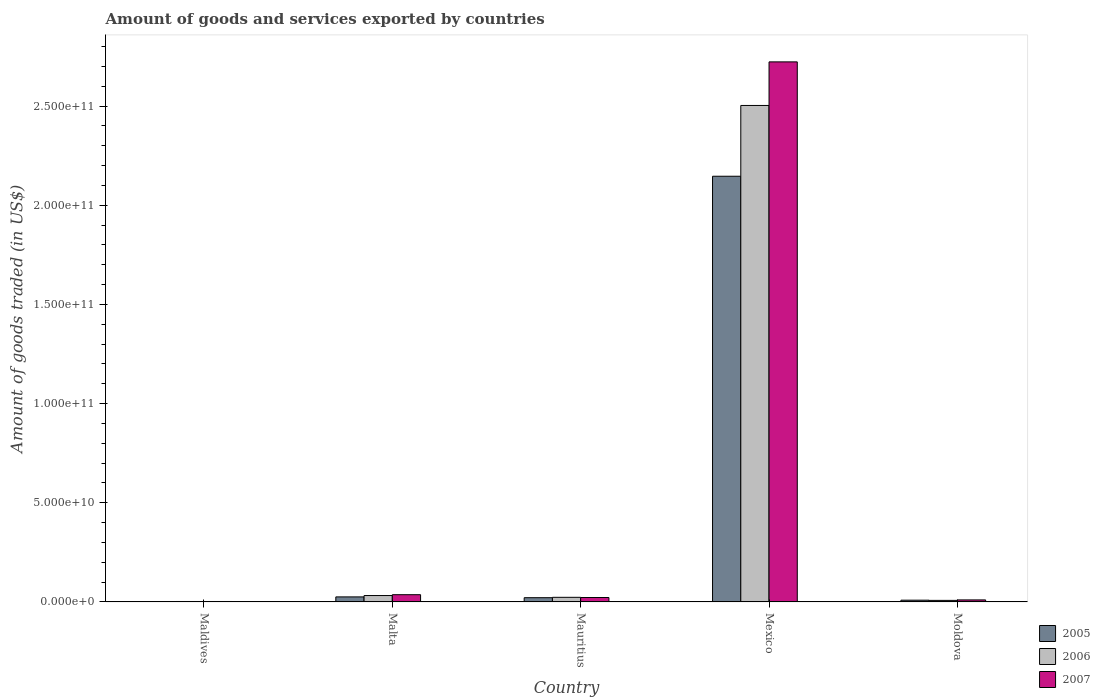How many different coloured bars are there?
Make the answer very short. 3. Are the number of bars on each tick of the X-axis equal?
Make the answer very short. Yes. What is the label of the 4th group of bars from the left?
Give a very brief answer. Mexico. In how many cases, is the number of bars for a given country not equal to the number of legend labels?
Your answer should be compact. 0. What is the total amount of goods and services exported in 2005 in Maldives?
Provide a succinct answer. 1.62e+08. Across all countries, what is the maximum total amount of goods and services exported in 2007?
Provide a short and direct response. 2.72e+11. Across all countries, what is the minimum total amount of goods and services exported in 2006?
Provide a succinct answer. 2.25e+08. In which country was the total amount of goods and services exported in 2007 maximum?
Your response must be concise. Mexico. In which country was the total amount of goods and services exported in 2005 minimum?
Your answer should be very brief. Maldives. What is the total total amount of goods and services exported in 2005 in the graph?
Make the answer very short. 2.20e+11. What is the difference between the total amount of goods and services exported in 2007 in Maldives and that in Moldova?
Your answer should be compact. -7.99e+08. What is the difference between the total amount of goods and services exported in 2007 in Malta and the total amount of goods and services exported in 2005 in Mexico?
Make the answer very short. -2.11e+11. What is the average total amount of goods and services exported in 2007 per country?
Give a very brief answer. 5.59e+1. What is the difference between the total amount of goods and services exported of/in 2005 and total amount of goods and services exported of/in 2006 in Mauritius?
Provide a short and direct response. -1.90e+08. What is the ratio of the total amount of goods and services exported in 2006 in Mauritius to that in Moldova?
Ensure brevity in your answer.  2.96. Is the difference between the total amount of goods and services exported in 2005 in Mauritius and Mexico greater than the difference between the total amount of goods and services exported in 2006 in Mauritius and Mexico?
Your response must be concise. Yes. What is the difference between the highest and the second highest total amount of goods and services exported in 2007?
Your response must be concise. 2.69e+11. What is the difference between the highest and the lowest total amount of goods and services exported in 2005?
Keep it short and to the point. 2.14e+11. Is it the case that in every country, the sum of the total amount of goods and services exported in 2007 and total amount of goods and services exported in 2005 is greater than the total amount of goods and services exported in 2006?
Keep it short and to the point. Yes. How many countries are there in the graph?
Ensure brevity in your answer.  5. What is the difference between two consecutive major ticks on the Y-axis?
Provide a short and direct response. 5.00e+1. Does the graph contain any zero values?
Give a very brief answer. No. Where does the legend appear in the graph?
Offer a terse response. Bottom right. What is the title of the graph?
Provide a short and direct response. Amount of goods and services exported by countries. What is the label or title of the X-axis?
Make the answer very short. Country. What is the label or title of the Y-axis?
Keep it short and to the point. Amount of goods traded (in US$). What is the Amount of goods traded (in US$) in 2005 in Maldives?
Ensure brevity in your answer.  1.62e+08. What is the Amount of goods traded (in US$) of 2006 in Maldives?
Your answer should be very brief. 2.25e+08. What is the Amount of goods traded (in US$) of 2007 in Maldives?
Your answer should be very brief. 2.27e+08. What is the Amount of goods traded (in US$) in 2005 in Malta?
Provide a short and direct response. 2.54e+09. What is the Amount of goods traded (in US$) of 2006 in Malta?
Provide a succinct answer. 3.23e+09. What is the Amount of goods traded (in US$) of 2007 in Malta?
Offer a terse response. 3.66e+09. What is the Amount of goods traded (in US$) in 2005 in Mauritius?
Keep it short and to the point. 2.14e+09. What is the Amount of goods traded (in US$) in 2006 in Mauritius?
Give a very brief answer. 2.33e+09. What is the Amount of goods traded (in US$) in 2007 in Mauritius?
Ensure brevity in your answer.  2.24e+09. What is the Amount of goods traded (in US$) in 2005 in Mexico?
Make the answer very short. 2.15e+11. What is the Amount of goods traded (in US$) of 2006 in Mexico?
Ensure brevity in your answer.  2.50e+11. What is the Amount of goods traded (in US$) in 2007 in Mexico?
Provide a short and direct response. 2.72e+11. What is the Amount of goods traded (in US$) in 2005 in Moldova?
Provide a short and direct response. 8.86e+08. What is the Amount of goods traded (in US$) of 2006 in Moldova?
Give a very brief answer. 7.87e+08. What is the Amount of goods traded (in US$) in 2007 in Moldova?
Make the answer very short. 1.03e+09. Across all countries, what is the maximum Amount of goods traded (in US$) of 2005?
Keep it short and to the point. 2.15e+11. Across all countries, what is the maximum Amount of goods traded (in US$) of 2006?
Your answer should be very brief. 2.50e+11. Across all countries, what is the maximum Amount of goods traded (in US$) in 2007?
Provide a succinct answer. 2.72e+11. Across all countries, what is the minimum Amount of goods traded (in US$) of 2005?
Offer a very short reply. 1.62e+08. Across all countries, what is the minimum Amount of goods traded (in US$) of 2006?
Ensure brevity in your answer.  2.25e+08. Across all countries, what is the minimum Amount of goods traded (in US$) in 2007?
Ensure brevity in your answer.  2.27e+08. What is the total Amount of goods traded (in US$) of 2005 in the graph?
Give a very brief answer. 2.20e+11. What is the total Amount of goods traded (in US$) in 2006 in the graph?
Your answer should be compact. 2.57e+11. What is the total Amount of goods traded (in US$) in 2007 in the graph?
Offer a very short reply. 2.79e+11. What is the difference between the Amount of goods traded (in US$) of 2005 in Maldives and that in Malta?
Your answer should be compact. -2.38e+09. What is the difference between the Amount of goods traded (in US$) in 2006 in Maldives and that in Malta?
Provide a succinct answer. -3.00e+09. What is the difference between the Amount of goods traded (in US$) of 2007 in Maldives and that in Malta?
Provide a short and direct response. -3.43e+09. What is the difference between the Amount of goods traded (in US$) of 2005 in Maldives and that in Mauritius?
Your answer should be very brief. -1.98e+09. What is the difference between the Amount of goods traded (in US$) of 2006 in Maldives and that in Mauritius?
Keep it short and to the point. -2.10e+09. What is the difference between the Amount of goods traded (in US$) of 2007 in Maldives and that in Mauritius?
Make the answer very short. -2.01e+09. What is the difference between the Amount of goods traded (in US$) in 2005 in Maldives and that in Mexico?
Make the answer very short. -2.14e+11. What is the difference between the Amount of goods traded (in US$) in 2006 in Maldives and that in Mexico?
Your response must be concise. -2.50e+11. What is the difference between the Amount of goods traded (in US$) of 2007 in Maldives and that in Mexico?
Keep it short and to the point. -2.72e+11. What is the difference between the Amount of goods traded (in US$) of 2005 in Maldives and that in Moldova?
Keep it short and to the point. -7.24e+08. What is the difference between the Amount of goods traded (in US$) of 2006 in Maldives and that in Moldova?
Provide a short and direct response. -5.62e+08. What is the difference between the Amount of goods traded (in US$) in 2007 in Maldives and that in Moldova?
Make the answer very short. -7.99e+08. What is the difference between the Amount of goods traded (in US$) in 2005 in Malta and that in Mauritius?
Ensure brevity in your answer.  4.06e+08. What is the difference between the Amount of goods traded (in US$) of 2006 in Malta and that in Mauritius?
Keep it short and to the point. 8.99e+08. What is the difference between the Amount of goods traded (in US$) in 2007 in Malta and that in Mauritius?
Provide a succinct answer. 1.42e+09. What is the difference between the Amount of goods traded (in US$) in 2005 in Malta and that in Mexico?
Ensure brevity in your answer.  -2.12e+11. What is the difference between the Amount of goods traded (in US$) of 2006 in Malta and that in Mexico?
Make the answer very short. -2.47e+11. What is the difference between the Amount of goods traded (in US$) of 2007 in Malta and that in Mexico?
Offer a very short reply. -2.69e+11. What is the difference between the Amount of goods traded (in US$) of 2005 in Malta and that in Moldova?
Your answer should be very brief. 1.66e+09. What is the difference between the Amount of goods traded (in US$) of 2006 in Malta and that in Moldova?
Give a very brief answer. 2.44e+09. What is the difference between the Amount of goods traded (in US$) of 2007 in Malta and that in Moldova?
Provide a succinct answer. 2.63e+09. What is the difference between the Amount of goods traded (in US$) in 2005 in Mauritius and that in Mexico?
Keep it short and to the point. -2.12e+11. What is the difference between the Amount of goods traded (in US$) of 2006 in Mauritius and that in Mexico?
Provide a short and direct response. -2.48e+11. What is the difference between the Amount of goods traded (in US$) of 2007 in Mauritius and that in Mexico?
Offer a terse response. -2.70e+11. What is the difference between the Amount of goods traded (in US$) of 2005 in Mauritius and that in Moldova?
Provide a short and direct response. 1.25e+09. What is the difference between the Amount of goods traded (in US$) of 2006 in Mauritius and that in Moldova?
Offer a terse response. 1.54e+09. What is the difference between the Amount of goods traded (in US$) in 2007 in Mauritius and that in Moldova?
Ensure brevity in your answer.  1.21e+09. What is the difference between the Amount of goods traded (in US$) in 2005 in Mexico and that in Moldova?
Your response must be concise. 2.14e+11. What is the difference between the Amount of goods traded (in US$) in 2006 in Mexico and that in Moldova?
Your answer should be compact. 2.50e+11. What is the difference between the Amount of goods traded (in US$) in 2007 in Mexico and that in Moldova?
Your answer should be compact. 2.71e+11. What is the difference between the Amount of goods traded (in US$) of 2005 in Maldives and the Amount of goods traded (in US$) of 2006 in Malta?
Provide a short and direct response. -3.07e+09. What is the difference between the Amount of goods traded (in US$) of 2005 in Maldives and the Amount of goods traded (in US$) of 2007 in Malta?
Make the answer very short. -3.50e+09. What is the difference between the Amount of goods traded (in US$) in 2006 in Maldives and the Amount of goods traded (in US$) in 2007 in Malta?
Keep it short and to the point. -3.43e+09. What is the difference between the Amount of goods traded (in US$) of 2005 in Maldives and the Amount of goods traded (in US$) of 2006 in Mauritius?
Give a very brief answer. -2.17e+09. What is the difference between the Amount of goods traded (in US$) of 2005 in Maldives and the Amount of goods traded (in US$) of 2007 in Mauritius?
Ensure brevity in your answer.  -2.08e+09. What is the difference between the Amount of goods traded (in US$) of 2006 in Maldives and the Amount of goods traded (in US$) of 2007 in Mauritius?
Offer a very short reply. -2.01e+09. What is the difference between the Amount of goods traded (in US$) in 2005 in Maldives and the Amount of goods traded (in US$) in 2006 in Mexico?
Provide a short and direct response. -2.50e+11. What is the difference between the Amount of goods traded (in US$) of 2005 in Maldives and the Amount of goods traded (in US$) of 2007 in Mexico?
Your answer should be very brief. -2.72e+11. What is the difference between the Amount of goods traded (in US$) in 2006 in Maldives and the Amount of goods traded (in US$) in 2007 in Mexico?
Offer a very short reply. -2.72e+11. What is the difference between the Amount of goods traded (in US$) in 2005 in Maldives and the Amount of goods traded (in US$) in 2006 in Moldova?
Provide a succinct answer. -6.25e+08. What is the difference between the Amount of goods traded (in US$) of 2005 in Maldives and the Amount of goods traded (in US$) of 2007 in Moldova?
Make the answer very short. -8.64e+08. What is the difference between the Amount of goods traded (in US$) of 2006 in Maldives and the Amount of goods traded (in US$) of 2007 in Moldova?
Your answer should be compact. -8.01e+08. What is the difference between the Amount of goods traded (in US$) of 2005 in Malta and the Amount of goods traded (in US$) of 2006 in Mauritius?
Your answer should be very brief. 2.16e+08. What is the difference between the Amount of goods traded (in US$) in 2005 in Malta and the Amount of goods traded (in US$) in 2007 in Mauritius?
Offer a terse response. 3.07e+08. What is the difference between the Amount of goods traded (in US$) in 2006 in Malta and the Amount of goods traded (in US$) in 2007 in Mauritius?
Give a very brief answer. 9.90e+08. What is the difference between the Amount of goods traded (in US$) in 2005 in Malta and the Amount of goods traded (in US$) in 2006 in Mexico?
Offer a very short reply. -2.48e+11. What is the difference between the Amount of goods traded (in US$) of 2005 in Malta and the Amount of goods traded (in US$) of 2007 in Mexico?
Your answer should be very brief. -2.70e+11. What is the difference between the Amount of goods traded (in US$) in 2006 in Malta and the Amount of goods traded (in US$) in 2007 in Mexico?
Provide a succinct answer. -2.69e+11. What is the difference between the Amount of goods traded (in US$) in 2005 in Malta and the Amount of goods traded (in US$) in 2006 in Moldova?
Offer a very short reply. 1.76e+09. What is the difference between the Amount of goods traded (in US$) in 2005 in Malta and the Amount of goods traded (in US$) in 2007 in Moldova?
Offer a terse response. 1.52e+09. What is the difference between the Amount of goods traded (in US$) in 2006 in Malta and the Amount of goods traded (in US$) in 2007 in Moldova?
Keep it short and to the point. 2.20e+09. What is the difference between the Amount of goods traded (in US$) in 2005 in Mauritius and the Amount of goods traded (in US$) in 2006 in Mexico?
Your answer should be compact. -2.48e+11. What is the difference between the Amount of goods traded (in US$) of 2005 in Mauritius and the Amount of goods traded (in US$) of 2007 in Mexico?
Ensure brevity in your answer.  -2.70e+11. What is the difference between the Amount of goods traded (in US$) in 2006 in Mauritius and the Amount of goods traded (in US$) in 2007 in Mexico?
Provide a succinct answer. -2.70e+11. What is the difference between the Amount of goods traded (in US$) of 2005 in Mauritius and the Amount of goods traded (in US$) of 2006 in Moldova?
Your answer should be compact. 1.35e+09. What is the difference between the Amount of goods traded (in US$) of 2005 in Mauritius and the Amount of goods traded (in US$) of 2007 in Moldova?
Your response must be concise. 1.11e+09. What is the difference between the Amount of goods traded (in US$) of 2006 in Mauritius and the Amount of goods traded (in US$) of 2007 in Moldova?
Keep it short and to the point. 1.30e+09. What is the difference between the Amount of goods traded (in US$) of 2005 in Mexico and the Amount of goods traded (in US$) of 2006 in Moldova?
Keep it short and to the point. 2.14e+11. What is the difference between the Amount of goods traded (in US$) in 2005 in Mexico and the Amount of goods traded (in US$) in 2007 in Moldova?
Ensure brevity in your answer.  2.14e+11. What is the difference between the Amount of goods traded (in US$) of 2006 in Mexico and the Amount of goods traded (in US$) of 2007 in Moldova?
Ensure brevity in your answer.  2.49e+11. What is the average Amount of goods traded (in US$) of 2005 per country?
Give a very brief answer. 4.41e+1. What is the average Amount of goods traded (in US$) in 2006 per country?
Your answer should be very brief. 5.14e+1. What is the average Amount of goods traded (in US$) of 2007 per country?
Keep it short and to the point. 5.59e+1. What is the difference between the Amount of goods traded (in US$) in 2005 and Amount of goods traded (in US$) in 2006 in Maldives?
Offer a terse response. -6.36e+07. What is the difference between the Amount of goods traded (in US$) in 2005 and Amount of goods traded (in US$) in 2007 in Maldives?
Your answer should be compact. -6.53e+07. What is the difference between the Amount of goods traded (in US$) of 2006 and Amount of goods traded (in US$) of 2007 in Maldives?
Your answer should be compact. -1.71e+06. What is the difference between the Amount of goods traded (in US$) in 2005 and Amount of goods traded (in US$) in 2006 in Malta?
Provide a short and direct response. -6.83e+08. What is the difference between the Amount of goods traded (in US$) of 2005 and Amount of goods traded (in US$) of 2007 in Malta?
Your response must be concise. -1.11e+09. What is the difference between the Amount of goods traded (in US$) of 2006 and Amount of goods traded (in US$) of 2007 in Malta?
Keep it short and to the point. -4.30e+08. What is the difference between the Amount of goods traded (in US$) of 2005 and Amount of goods traded (in US$) of 2006 in Mauritius?
Make the answer very short. -1.90e+08. What is the difference between the Amount of goods traded (in US$) of 2005 and Amount of goods traded (in US$) of 2007 in Mauritius?
Give a very brief answer. -9.95e+07. What is the difference between the Amount of goods traded (in US$) of 2006 and Amount of goods traded (in US$) of 2007 in Mauritius?
Offer a very short reply. 9.09e+07. What is the difference between the Amount of goods traded (in US$) in 2005 and Amount of goods traded (in US$) in 2006 in Mexico?
Offer a terse response. -3.57e+1. What is the difference between the Amount of goods traded (in US$) in 2005 and Amount of goods traded (in US$) in 2007 in Mexico?
Provide a short and direct response. -5.77e+1. What is the difference between the Amount of goods traded (in US$) of 2006 and Amount of goods traded (in US$) of 2007 in Mexico?
Keep it short and to the point. -2.20e+1. What is the difference between the Amount of goods traded (in US$) in 2005 and Amount of goods traded (in US$) in 2006 in Moldova?
Keep it short and to the point. 9.92e+07. What is the difference between the Amount of goods traded (in US$) of 2005 and Amount of goods traded (in US$) of 2007 in Moldova?
Your response must be concise. -1.40e+08. What is the difference between the Amount of goods traded (in US$) in 2006 and Amount of goods traded (in US$) in 2007 in Moldova?
Offer a terse response. -2.39e+08. What is the ratio of the Amount of goods traded (in US$) in 2005 in Maldives to that in Malta?
Provide a succinct answer. 0.06. What is the ratio of the Amount of goods traded (in US$) of 2006 in Maldives to that in Malta?
Provide a succinct answer. 0.07. What is the ratio of the Amount of goods traded (in US$) in 2007 in Maldives to that in Malta?
Your answer should be very brief. 0.06. What is the ratio of the Amount of goods traded (in US$) in 2005 in Maldives to that in Mauritius?
Your answer should be compact. 0.08. What is the ratio of the Amount of goods traded (in US$) in 2006 in Maldives to that in Mauritius?
Your answer should be very brief. 0.1. What is the ratio of the Amount of goods traded (in US$) of 2007 in Maldives to that in Mauritius?
Give a very brief answer. 0.1. What is the ratio of the Amount of goods traded (in US$) of 2005 in Maldives to that in Mexico?
Provide a short and direct response. 0. What is the ratio of the Amount of goods traded (in US$) of 2006 in Maldives to that in Mexico?
Your response must be concise. 0. What is the ratio of the Amount of goods traded (in US$) in 2007 in Maldives to that in Mexico?
Offer a terse response. 0. What is the ratio of the Amount of goods traded (in US$) in 2005 in Maldives to that in Moldova?
Offer a terse response. 0.18. What is the ratio of the Amount of goods traded (in US$) in 2006 in Maldives to that in Moldova?
Offer a terse response. 0.29. What is the ratio of the Amount of goods traded (in US$) in 2007 in Maldives to that in Moldova?
Ensure brevity in your answer.  0.22. What is the ratio of the Amount of goods traded (in US$) in 2005 in Malta to that in Mauritius?
Your answer should be very brief. 1.19. What is the ratio of the Amount of goods traded (in US$) of 2006 in Malta to that in Mauritius?
Offer a very short reply. 1.39. What is the ratio of the Amount of goods traded (in US$) in 2007 in Malta to that in Mauritius?
Make the answer very short. 1.63. What is the ratio of the Amount of goods traded (in US$) in 2005 in Malta to that in Mexico?
Keep it short and to the point. 0.01. What is the ratio of the Amount of goods traded (in US$) in 2006 in Malta to that in Mexico?
Keep it short and to the point. 0.01. What is the ratio of the Amount of goods traded (in US$) in 2007 in Malta to that in Mexico?
Provide a succinct answer. 0.01. What is the ratio of the Amount of goods traded (in US$) in 2005 in Malta to that in Moldova?
Your answer should be compact. 2.87. What is the ratio of the Amount of goods traded (in US$) of 2006 in Malta to that in Moldova?
Give a very brief answer. 4.1. What is the ratio of the Amount of goods traded (in US$) in 2007 in Malta to that in Moldova?
Make the answer very short. 3.56. What is the ratio of the Amount of goods traded (in US$) in 2006 in Mauritius to that in Mexico?
Provide a succinct answer. 0.01. What is the ratio of the Amount of goods traded (in US$) in 2007 in Mauritius to that in Mexico?
Keep it short and to the point. 0.01. What is the ratio of the Amount of goods traded (in US$) of 2005 in Mauritius to that in Moldova?
Your answer should be compact. 2.41. What is the ratio of the Amount of goods traded (in US$) of 2006 in Mauritius to that in Moldova?
Provide a succinct answer. 2.96. What is the ratio of the Amount of goods traded (in US$) in 2007 in Mauritius to that in Moldova?
Offer a terse response. 2.18. What is the ratio of the Amount of goods traded (in US$) of 2005 in Mexico to that in Moldova?
Ensure brevity in your answer.  242.22. What is the ratio of the Amount of goods traded (in US$) of 2006 in Mexico to that in Moldova?
Your response must be concise. 318.09. What is the ratio of the Amount of goods traded (in US$) in 2007 in Mexico to that in Moldova?
Offer a terse response. 265.39. What is the difference between the highest and the second highest Amount of goods traded (in US$) in 2005?
Offer a very short reply. 2.12e+11. What is the difference between the highest and the second highest Amount of goods traded (in US$) in 2006?
Offer a very short reply. 2.47e+11. What is the difference between the highest and the second highest Amount of goods traded (in US$) of 2007?
Your answer should be very brief. 2.69e+11. What is the difference between the highest and the lowest Amount of goods traded (in US$) of 2005?
Make the answer very short. 2.14e+11. What is the difference between the highest and the lowest Amount of goods traded (in US$) in 2006?
Ensure brevity in your answer.  2.50e+11. What is the difference between the highest and the lowest Amount of goods traded (in US$) of 2007?
Ensure brevity in your answer.  2.72e+11. 